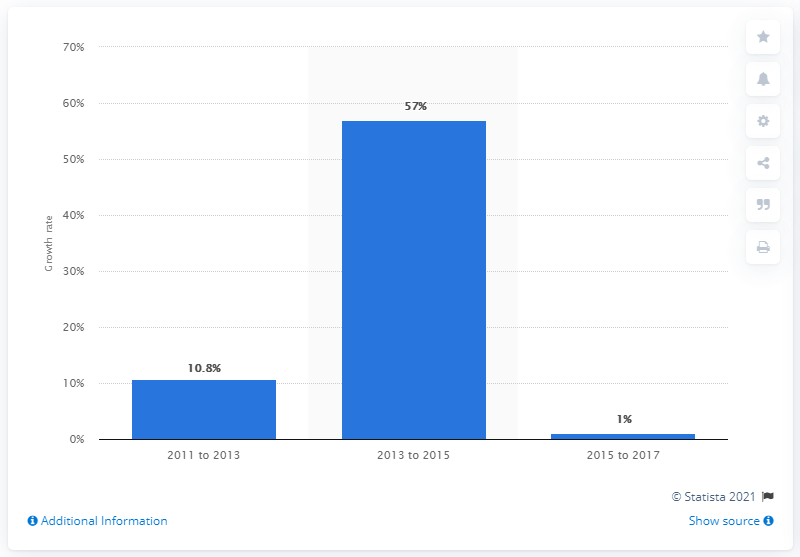Indicate a few pertinent items in this graphic. The growth rate of the SRI market in the second period observed was 57%. 